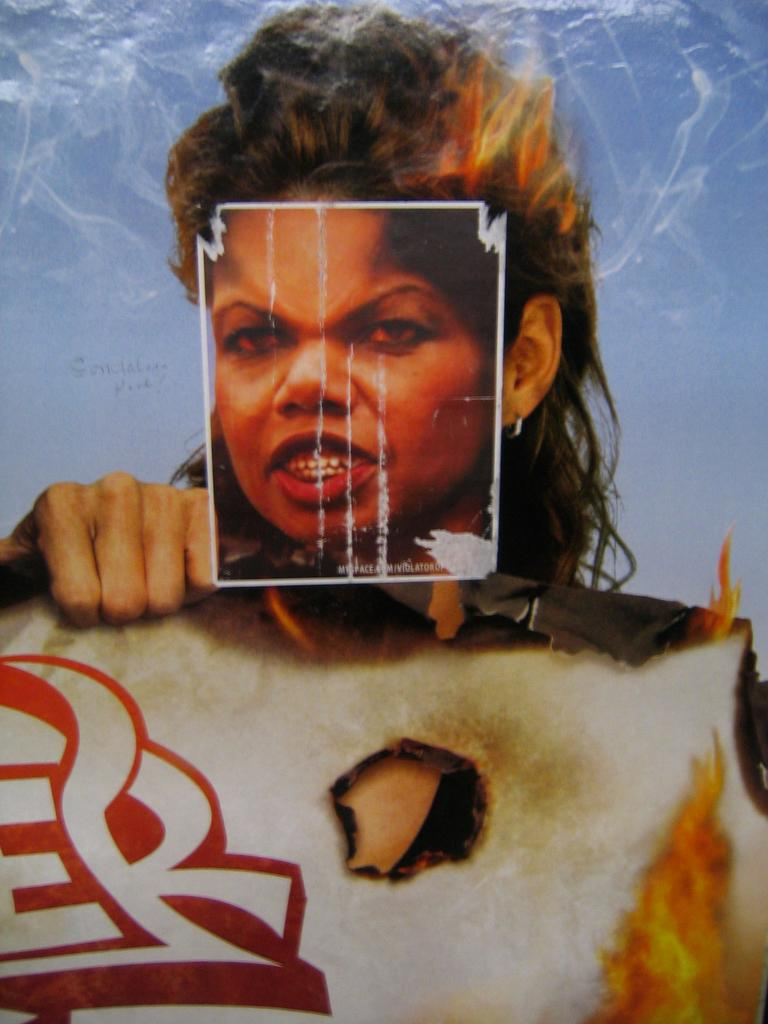What is present on the banner in the image? There is a person and fire depicted on the banner in the image. Can you describe the person on the banner? Unfortunately, the details of the person on the banner cannot be determined from the image alone. What is the purpose of the fire depicted on the banner? The purpose of the fire depicted on the banner cannot be determined from the image alone. What is the latest news about the number of people attending the event depicted on the banner? There is no information about the number of people attending the event or any news related to the event in the image. 